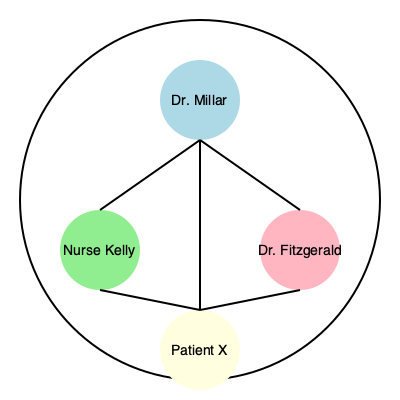Analyze the network diagram representing character relationships in Doctor Millar's show. Which character serves as the central node, connecting all other characters, and what does this suggest about their role in the narrative? To analyze the network diagram and identify the central character, we need to follow these steps:

1. Identify all characters in the diagram:
   - Dr. Millar
   - Nurse Kelly
   - Dr. Fitzgerald
   - Patient X

2. Examine the connections between characters:
   - Dr. Millar is connected to all other characters
   - Nurse Kelly is connected to Dr. Millar and Patient X
   - Dr. Fitzgerald is connected to Dr. Millar and Patient X
   - Patient X is connected to all other characters

3. Determine the central node:
   - Dr. Millar has direct connections to all other characters
   - No other character has connections to all others

4. Interpret the significance of the central node:
   - As the central node, Dr. Millar likely plays a pivotal role in the narrative
   - This position suggests that Dr. Millar is the main character or protagonist
   - Dr. Millar's connections imply involvement in all major storylines and character interactions

5. Consider the implications for the show's structure:
   - The network structure indicates that most plots and character developments likely revolve around Dr. Millar
   - Other characters' stories may be explored through their interactions with Dr. Millar

In conclusion, Dr. Millar serves as the central node in the network, suggesting a crucial role as the main character and the primary driving force of the show's narrative.
Answer: Dr. Millar; central protagonist driving the narrative 